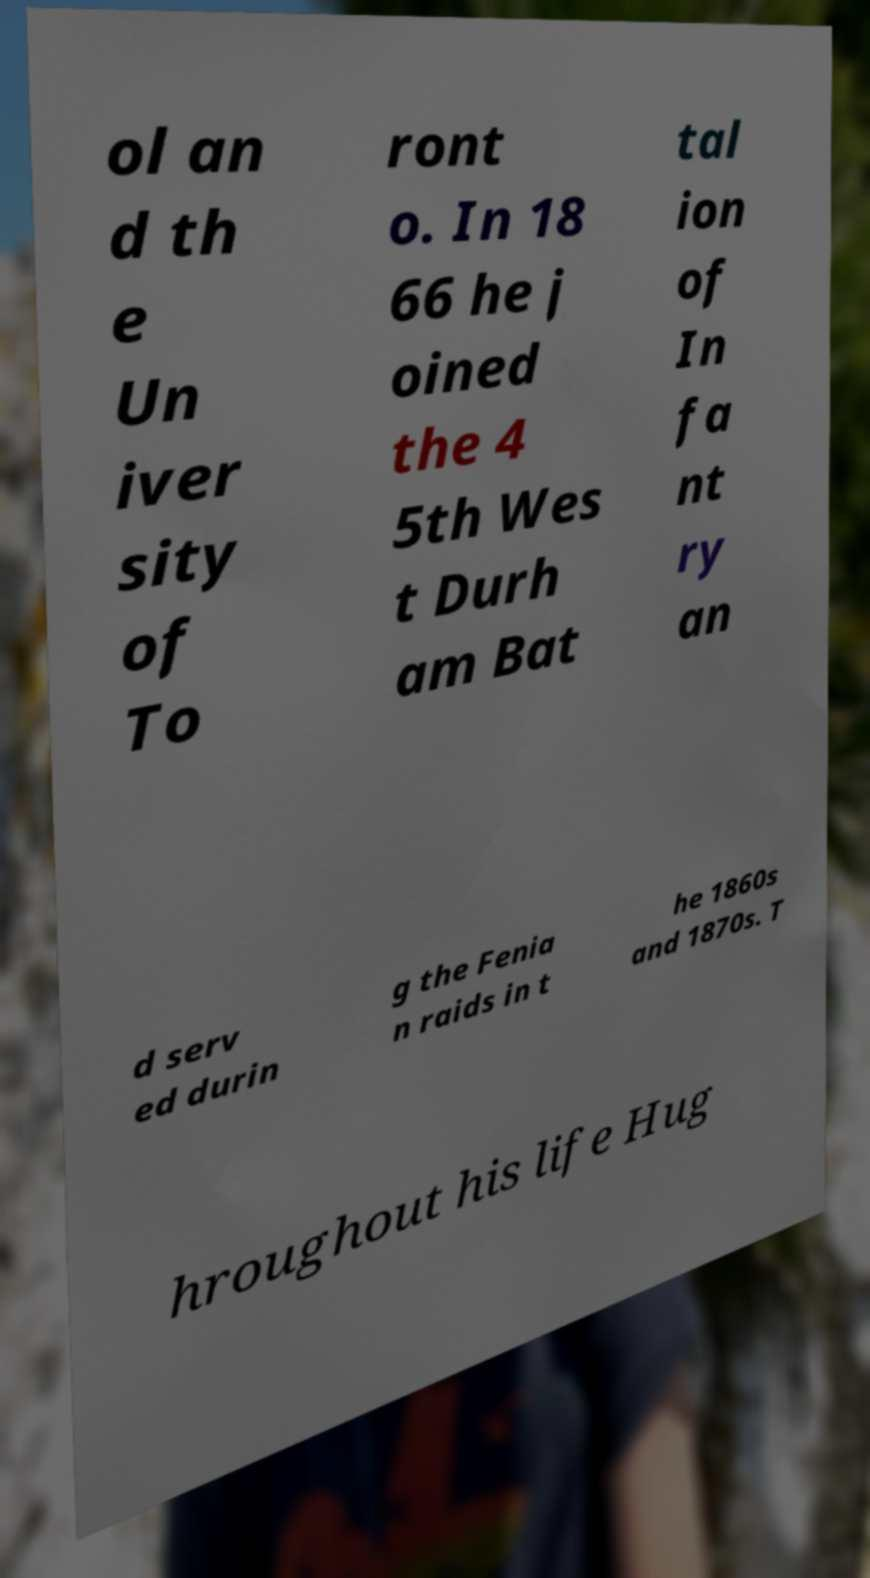Can you accurately transcribe the text from the provided image for me? ol an d th e Un iver sity of To ront o. In 18 66 he j oined the 4 5th Wes t Durh am Bat tal ion of In fa nt ry an d serv ed durin g the Fenia n raids in t he 1860s and 1870s. T hroughout his life Hug 